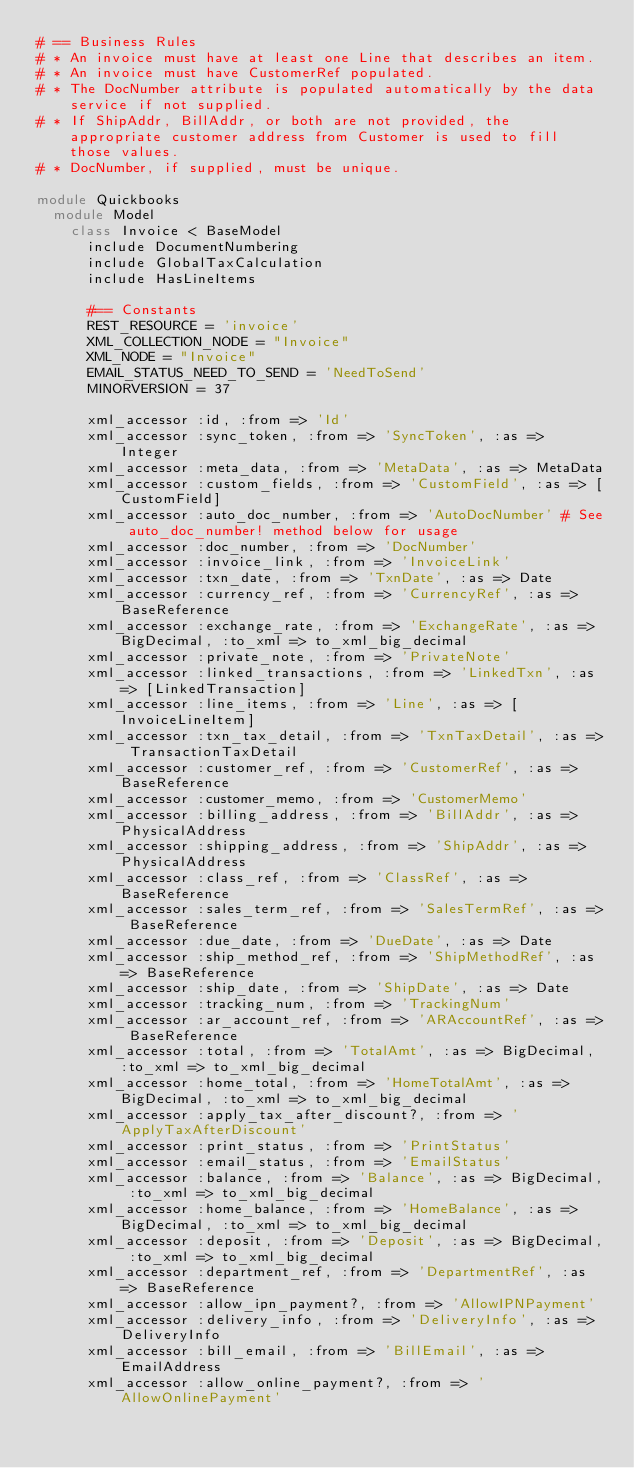Convert code to text. <code><loc_0><loc_0><loc_500><loc_500><_Ruby_># == Business Rules
# * An invoice must have at least one Line that describes an item.
# * An invoice must have CustomerRef populated.
# * The DocNumber attribute is populated automatically by the data service if not supplied.
# * If ShipAddr, BillAddr, or both are not provided, the appropriate customer address from Customer is used to fill those values.
# * DocNumber, if supplied, must be unique.

module Quickbooks
  module Model
    class Invoice < BaseModel
      include DocumentNumbering
      include GlobalTaxCalculation
      include HasLineItems

      #== Constants
      REST_RESOURCE = 'invoice'
      XML_COLLECTION_NODE = "Invoice"
      XML_NODE = "Invoice"
      EMAIL_STATUS_NEED_TO_SEND = 'NeedToSend'
      MINORVERSION = 37

      xml_accessor :id, :from => 'Id'
      xml_accessor :sync_token, :from => 'SyncToken', :as => Integer
      xml_accessor :meta_data, :from => 'MetaData', :as => MetaData
      xml_accessor :custom_fields, :from => 'CustomField', :as => [CustomField]
      xml_accessor :auto_doc_number, :from => 'AutoDocNumber' # See auto_doc_number! method below for usage
      xml_accessor :doc_number, :from => 'DocNumber'
      xml_accessor :invoice_link, :from => 'InvoiceLink'
      xml_accessor :txn_date, :from => 'TxnDate', :as => Date
      xml_accessor :currency_ref, :from => 'CurrencyRef', :as => BaseReference
      xml_accessor :exchange_rate, :from => 'ExchangeRate', :as => BigDecimal, :to_xml => to_xml_big_decimal
      xml_accessor :private_note, :from => 'PrivateNote'
      xml_accessor :linked_transactions, :from => 'LinkedTxn', :as => [LinkedTransaction]
      xml_accessor :line_items, :from => 'Line', :as => [InvoiceLineItem]
      xml_accessor :txn_tax_detail, :from => 'TxnTaxDetail', :as => TransactionTaxDetail
      xml_accessor :customer_ref, :from => 'CustomerRef', :as => BaseReference
      xml_accessor :customer_memo, :from => 'CustomerMemo'
      xml_accessor :billing_address, :from => 'BillAddr', :as => PhysicalAddress
      xml_accessor :shipping_address, :from => 'ShipAddr', :as => PhysicalAddress
      xml_accessor :class_ref, :from => 'ClassRef', :as => BaseReference
      xml_accessor :sales_term_ref, :from => 'SalesTermRef', :as => BaseReference
      xml_accessor :due_date, :from => 'DueDate', :as => Date
      xml_accessor :ship_method_ref, :from => 'ShipMethodRef', :as => BaseReference
      xml_accessor :ship_date, :from => 'ShipDate', :as => Date
      xml_accessor :tracking_num, :from => 'TrackingNum'
      xml_accessor :ar_account_ref, :from => 'ARAccountRef', :as => BaseReference
      xml_accessor :total, :from => 'TotalAmt', :as => BigDecimal, :to_xml => to_xml_big_decimal
      xml_accessor :home_total, :from => 'HomeTotalAmt', :as => BigDecimal, :to_xml => to_xml_big_decimal
      xml_accessor :apply_tax_after_discount?, :from => 'ApplyTaxAfterDiscount'
      xml_accessor :print_status, :from => 'PrintStatus'
      xml_accessor :email_status, :from => 'EmailStatus'
      xml_accessor :balance, :from => 'Balance', :as => BigDecimal, :to_xml => to_xml_big_decimal
      xml_accessor :home_balance, :from => 'HomeBalance', :as => BigDecimal, :to_xml => to_xml_big_decimal
      xml_accessor :deposit, :from => 'Deposit', :as => BigDecimal, :to_xml => to_xml_big_decimal
      xml_accessor :department_ref, :from => 'DepartmentRef', :as => BaseReference
      xml_accessor :allow_ipn_payment?, :from => 'AllowIPNPayment'
      xml_accessor :delivery_info, :from => 'DeliveryInfo', :as => DeliveryInfo
      xml_accessor :bill_email, :from => 'BillEmail', :as => EmailAddress
      xml_accessor :allow_online_payment?, :from => 'AllowOnlinePayment'</code> 